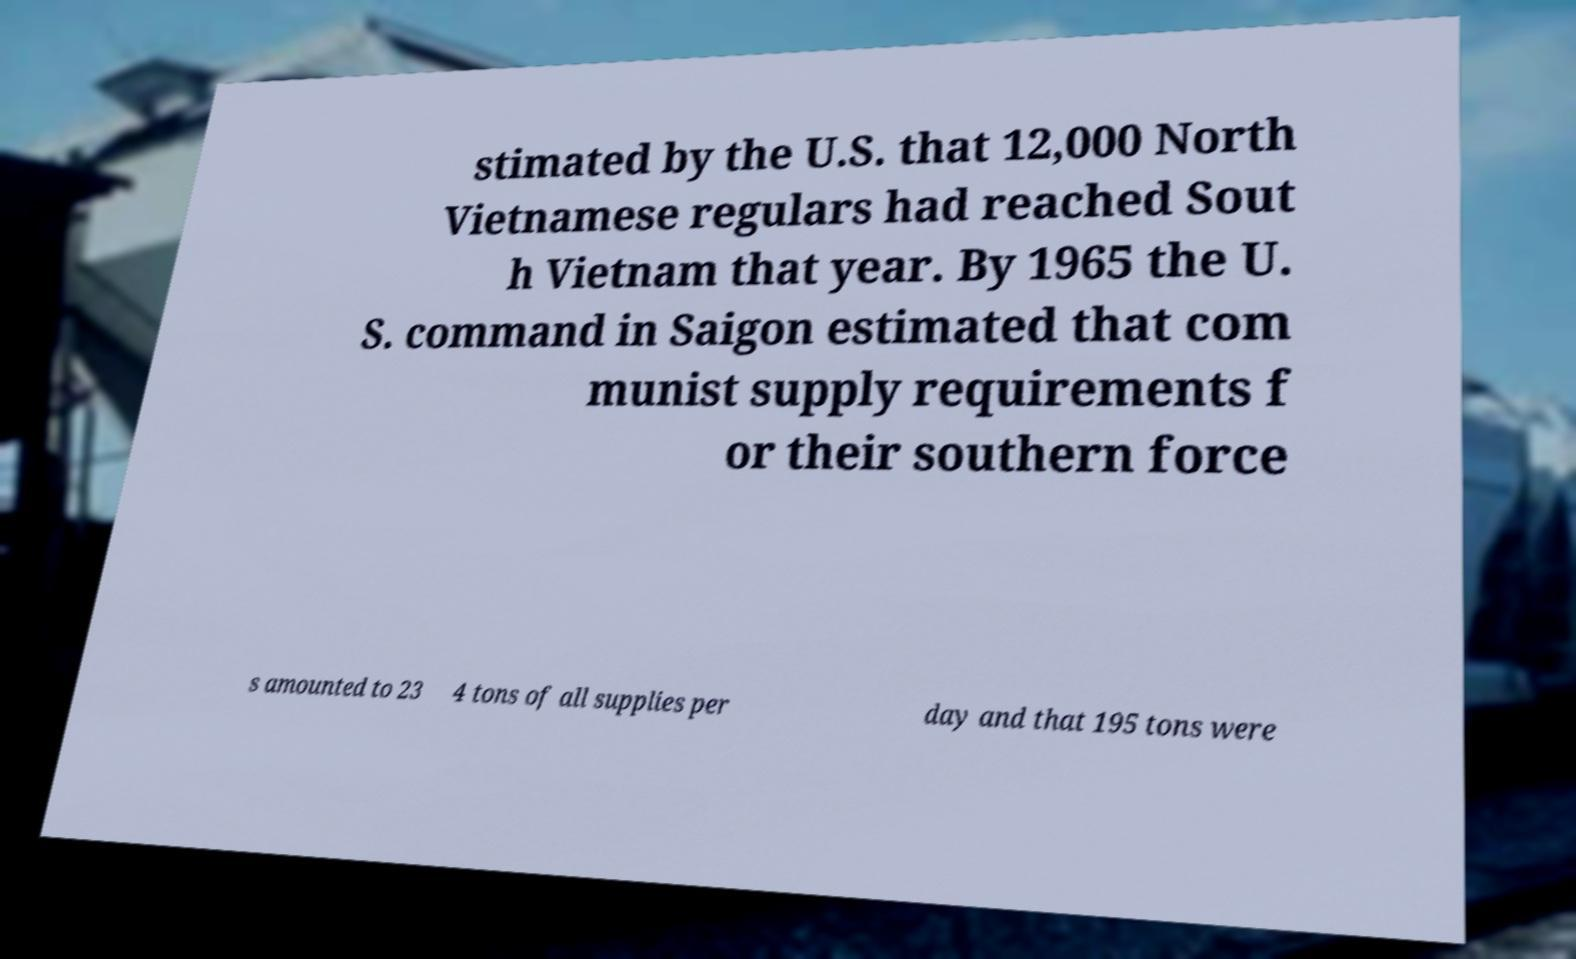Please identify and transcribe the text found in this image. stimated by the U.S. that 12,000 North Vietnamese regulars had reached Sout h Vietnam that year. By 1965 the U. S. command in Saigon estimated that com munist supply requirements f or their southern force s amounted to 23 4 tons of all supplies per day and that 195 tons were 